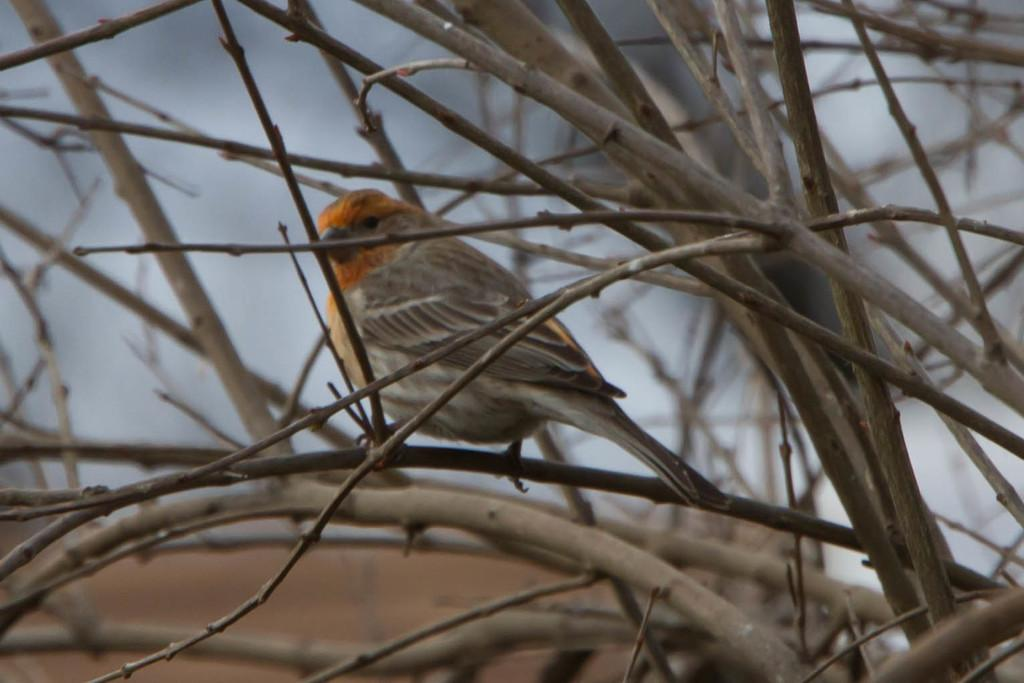What type of animal can be seen in the image? There is a bird in the image. What is the bird perched on in the image? The bird is perched on branches visible in the image. How would you describe the background of the image? The background of the image is blurry. What is the profit margin of the bird in the image? There is no information about profit margins in the image, as it features a bird perched on branches with a blurry background. 